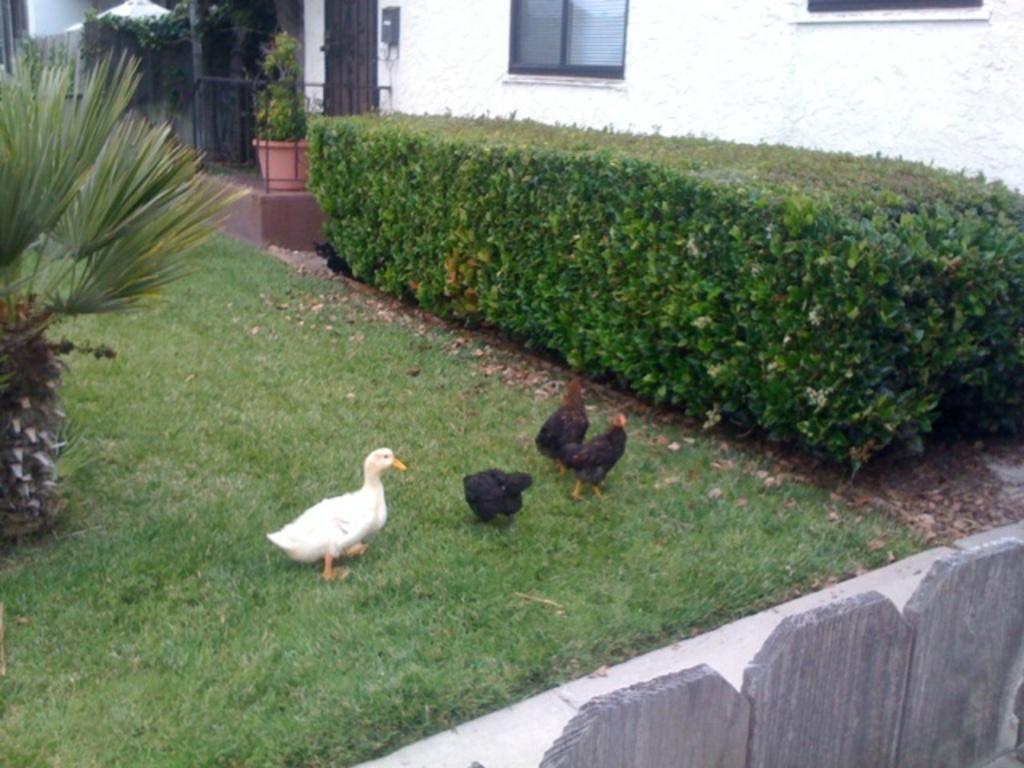Can you describe this image briefly? In this picture we can see a few birds on the grass. There is a wall visible in the bottom right. We can see a plant on the left side. There are a few plants, a house plant, fence and a building is visible in the background. 